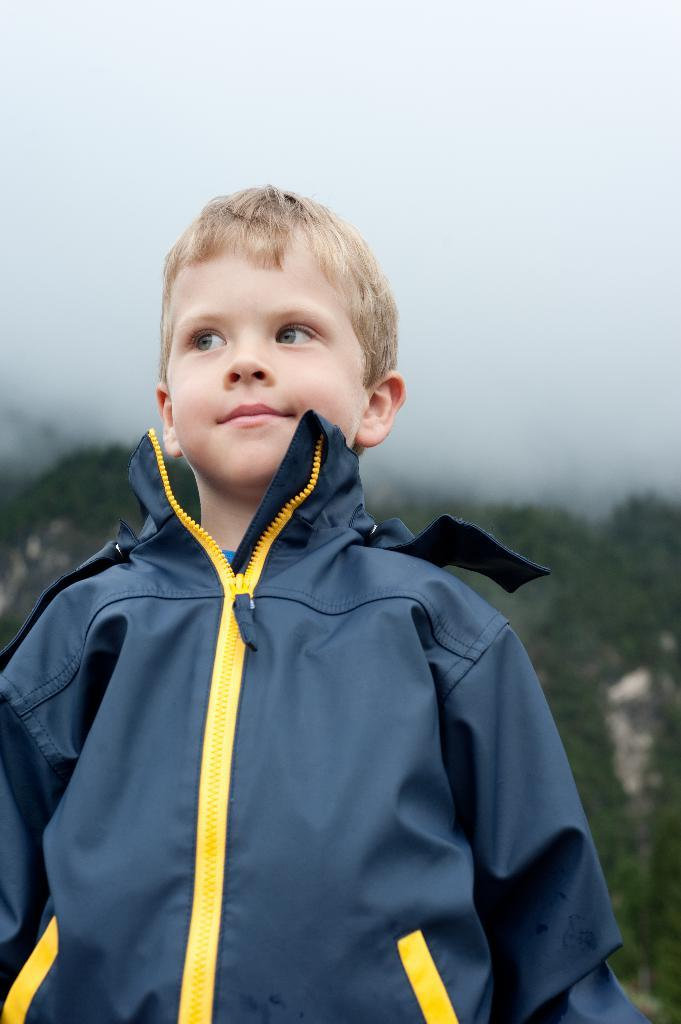What is the main subject of the image? There is a child in the image. What is the child wearing? The child is wearing a blue and yellow jacket. What can be seen in the background of the image? There are trees and the sky visible in the background of the image. What is the color of the trees in the image? The trees are green in color. What type of dog is the child walking in the image? There is no dog present in the image; the child is not walking. What is the purpose of the coat in the image? There is no coat mentioned in the image; the child is wearing a jacket. 